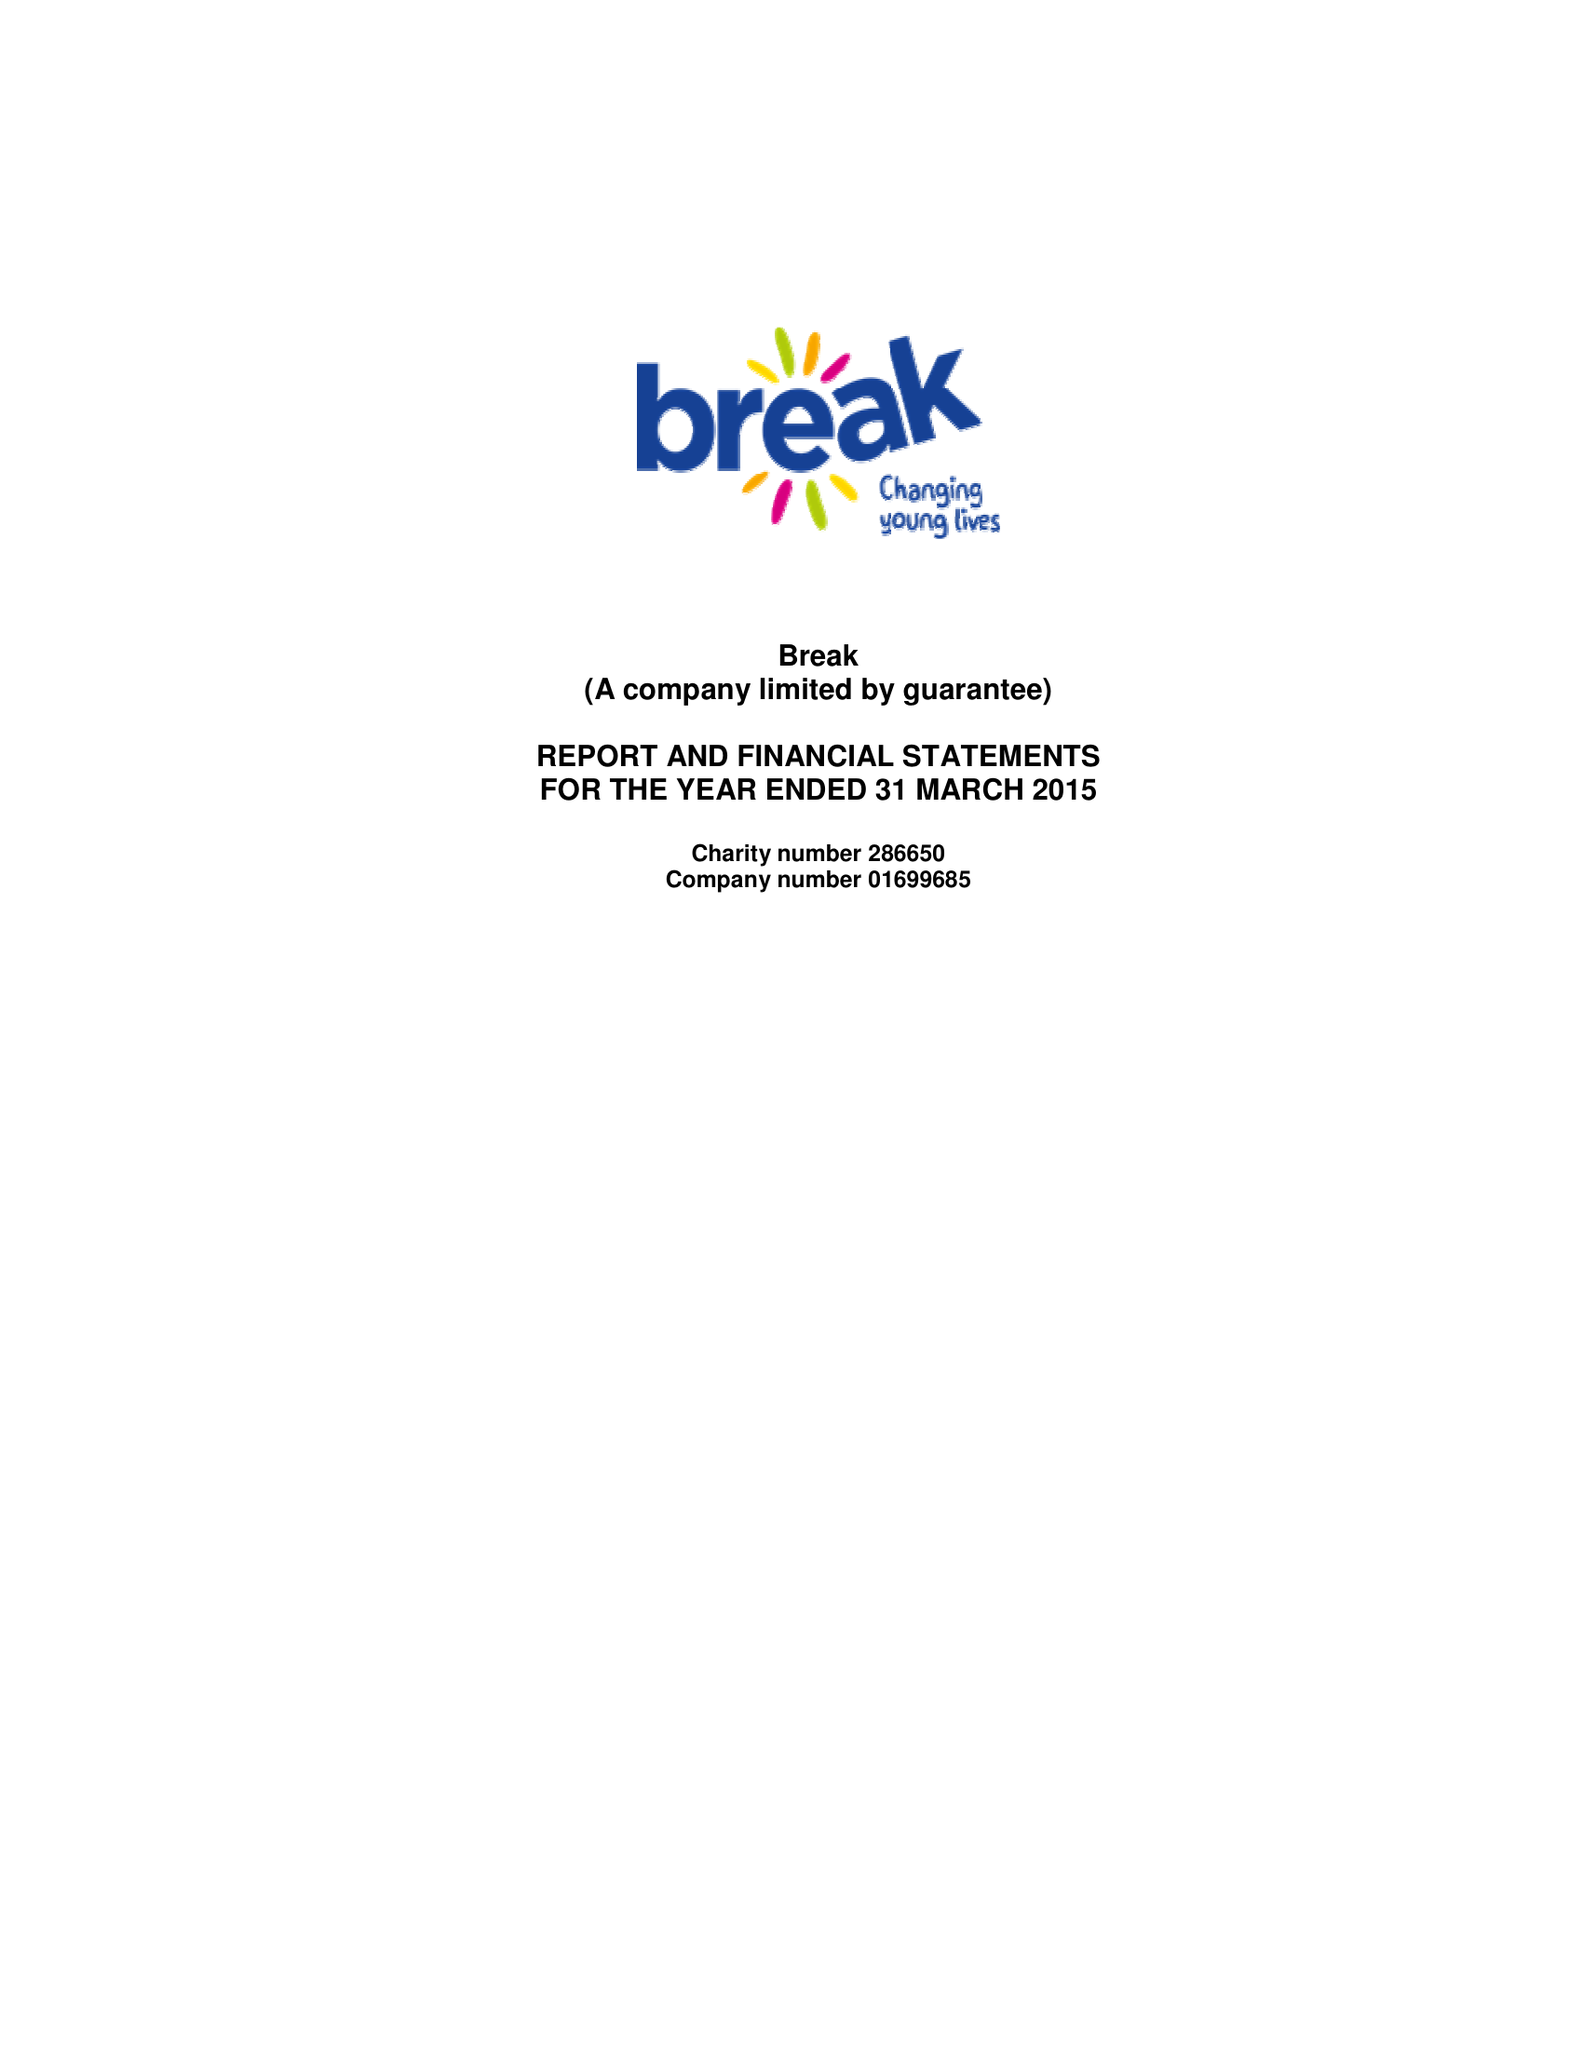What is the value for the address__postcode?
Answer the question using a single word or phrase. NR6 6BX 